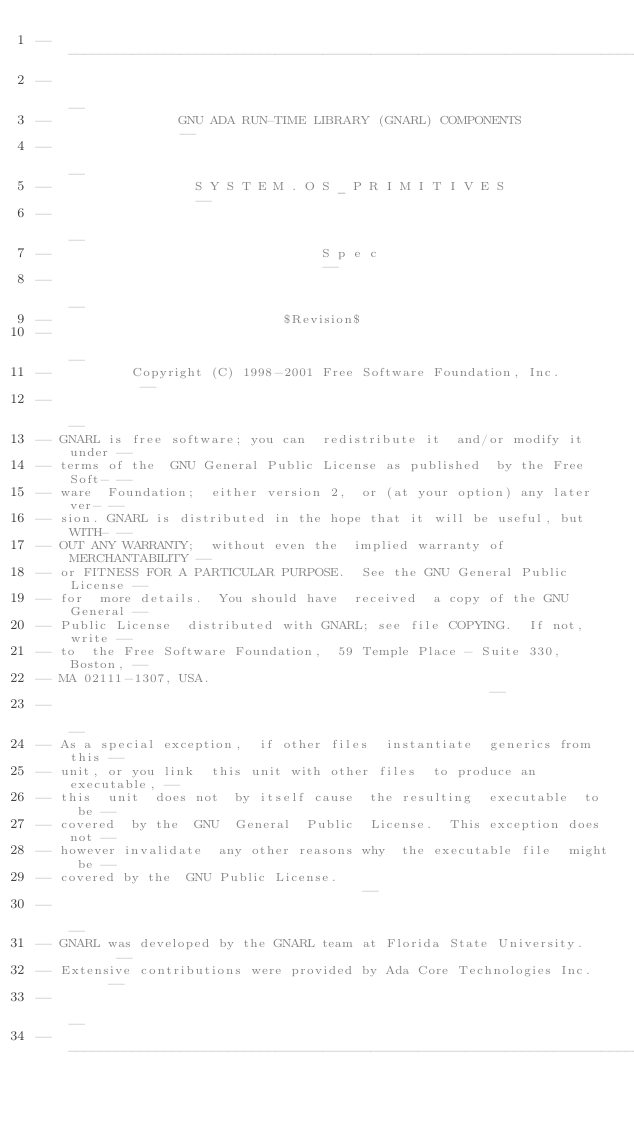Convert code to text. <code><loc_0><loc_0><loc_500><loc_500><_Ada_>------------------------------------------------------------------------------
--                                                                          --
--                GNU ADA RUN-TIME LIBRARY (GNARL) COMPONENTS               --
--                                                                          --
--                  S Y S T E M . O S _ P R I M I T I V E S                 --
--                                                                          --
--                                  S p e c                                 --
--                                                                          --
--                             $Revision$
--                                                                          --
--          Copyright (C) 1998-2001 Free Software Foundation, Inc.          --
--                                                                          --
-- GNARL is free software; you can  redistribute it  and/or modify it under --
-- terms of the  GNU General Public License as published  by the Free Soft- --
-- ware  Foundation;  either version 2,  or (at your option) any later ver- --
-- sion. GNARL is distributed in the hope that it will be useful, but WITH- --
-- OUT ANY WARRANTY;  without even the  implied warranty of MERCHANTABILITY --
-- or FITNESS FOR A PARTICULAR PURPOSE.  See the GNU General Public License --
-- for  more details.  You should have  received  a copy of the GNU General --
-- Public License  distributed with GNARL; see file COPYING.  If not, write --
-- to  the Free Software Foundation,  59 Temple Place - Suite 330,  Boston, --
-- MA 02111-1307, USA.                                                      --
--                                                                          --
-- As a special exception,  if other files  instantiate  generics from this --
-- unit, or you link  this unit with other files  to produce an executable, --
-- this  unit  does not  by itself cause  the resulting  executable  to  be --
-- covered  by the  GNU  General  Public  License.  This exception does not --
-- however invalidate  any other reasons why  the executable file  might be --
-- covered by the  GNU Public License.                                      --
--                                                                          --
-- GNARL was developed by the GNARL team at Florida State University.       --
-- Extensive contributions were provided by Ada Core Technologies Inc.      --
--                                                                          --
------------------------------------------------------------------------------
</code> 